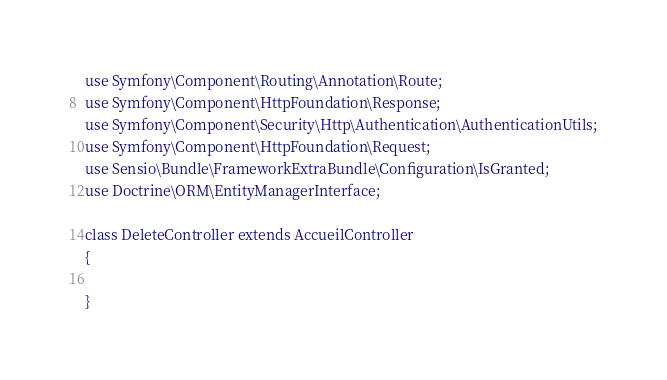Convert code to text. <code><loc_0><loc_0><loc_500><loc_500><_PHP_>use Symfony\Component\Routing\Annotation\Route;
use Symfony\Component\HttpFoundation\Response;
use Symfony\Component\Security\Http\Authentication\AuthenticationUtils;
use Symfony\Component\HttpFoundation\Request;
use Sensio\Bundle\FrameworkExtraBundle\Configuration\IsGranted;
use Doctrine\ORM\EntityManagerInterface;

class DeleteController extends AccueilController
{
            
}</code> 